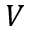Convert formula to latex. <formula><loc_0><loc_0><loc_500><loc_500>V</formula> 